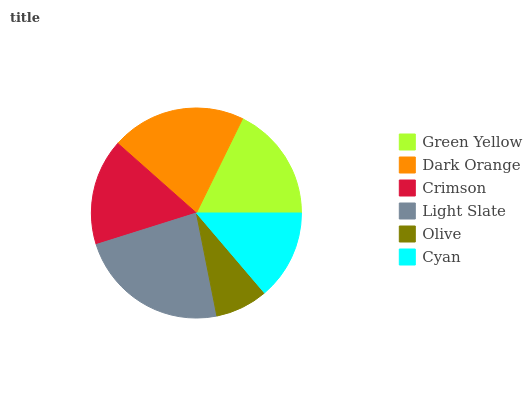Is Olive the minimum?
Answer yes or no. Yes. Is Light Slate the maximum?
Answer yes or no. Yes. Is Dark Orange the minimum?
Answer yes or no. No. Is Dark Orange the maximum?
Answer yes or no. No. Is Dark Orange greater than Green Yellow?
Answer yes or no. Yes. Is Green Yellow less than Dark Orange?
Answer yes or no. Yes. Is Green Yellow greater than Dark Orange?
Answer yes or no. No. Is Dark Orange less than Green Yellow?
Answer yes or no. No. Is Green Yellow the high median?
Answer yes or no. Yes. Is Crimson the low median?
Answer yes or no. Yes. Is Crimson the high median?
Answer yes or no. No. Is Olive the low median?
Answer yes or no. No. 